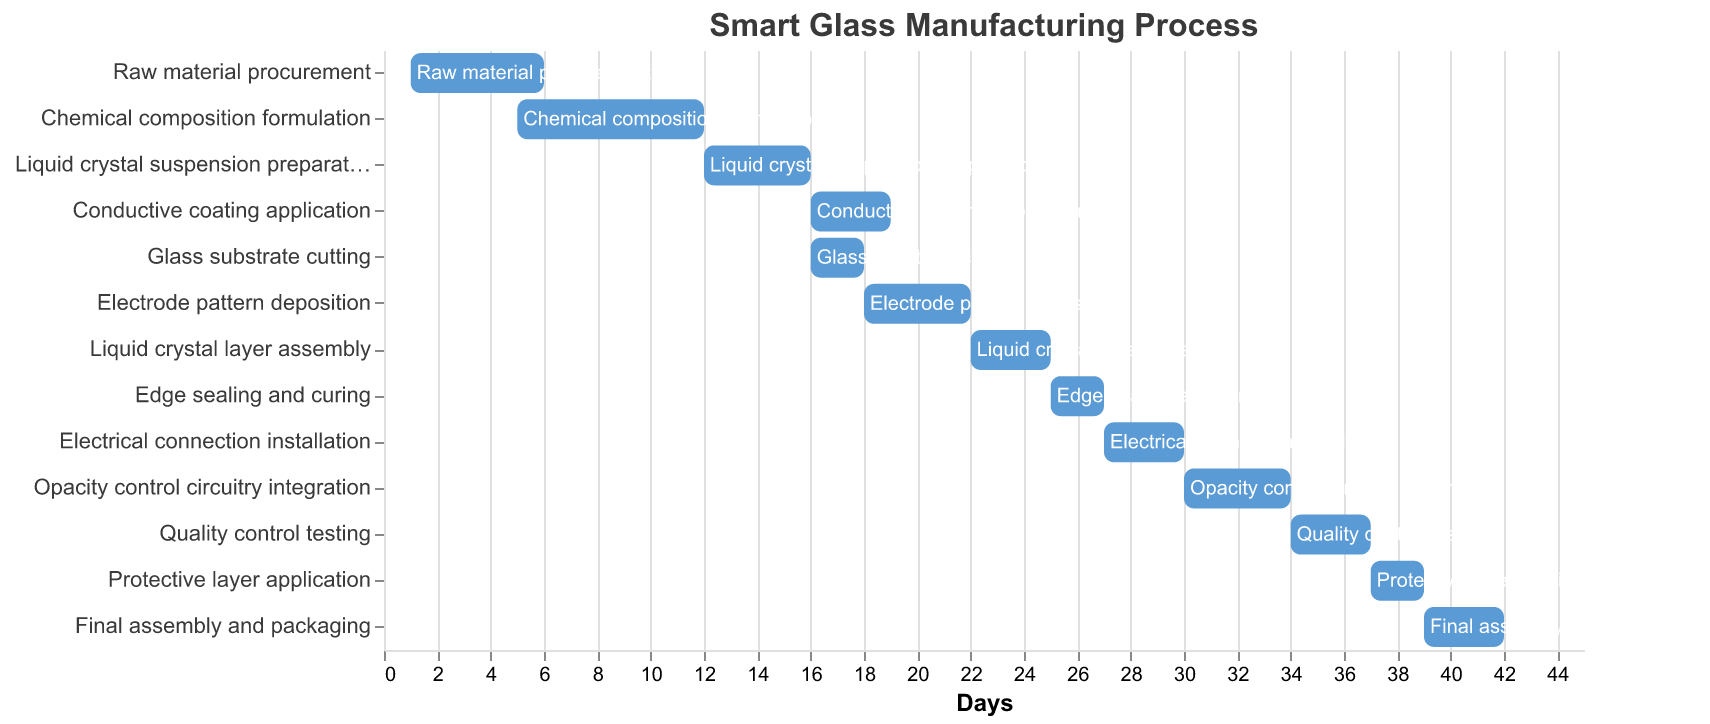What is the task with the longest duration? To find the task with the longest duration, look at the "Duration" field for each task and compare. "Chemical composition formulation" lasts for 7 days, which is the longest.
Answer: Chemical composition formulation When does the "Electrode pattern deposition" task start and end? Refer to the "Start" and "Duration" fields for "Electrode pattern deposition". It starts on day 18 and lasts 4 days. Thus, it ends on day 22 (18 + 4 = 22).
Answer: Starts on day 18 and ends on day 22 Which tasks overlap exactly in their start days? Identify tasks with the same "Start" day. "Conductive coating application" and "Glass substrate cutting" both start on day 16.
Answer: Conductive coating application and Glass substrate cutting What is the total duration of tasks starting before day 10? Identify tasks starting before day 10: "Raw material procurement" (5 days) and "Chemical composition formulation" (7 days started at day 5, but overlapping counts). Total duration is the sum of these, as per their "Duration" fields.
Answer: 12 days When does the final task, "Final assembly and packaging," finish? Look at the "Start" and "Duration" of "Final assembly and packaging". It starts on day 39 and lasts 3 days, so it ends on day 42 (39 + 3 = 42).
Answer: Day 42 How many tasks take exactly 3 days to complete? Check the "Duration" field for tasks lasting 3 days: "Conductive coating application", "Liquid crystal layer assembly", "Electrical connection installation", "Opacity control circuitry integration", "Quality control testing", and "Final assembly and packaging".
Answer: Six tasks What is the average task duration for tasks starting after day 10? Identify tasks starting after day 10 and their durations: "Liquid crystal suspension preparation" (4 days), "Conductive coating application" (3 days), "Glass substrate cutting" (2 days), "Electrode pattern deposition" (4 days), "Liquid crystal layer assembly" (3 days), "Edge sealing and curing" (2 days), "Electrical connection installation" (3 days), "Opacity control circuitry integration" (4 days), "Quality control testing" (3 days), "Protective layer application" (2 days), "Final assembly and packaging" (3 days). Average duration = (4+3+2+4+3+2+3+4+3+2+3)/11 = 3
Answer: 3 days What is the most common task duration? By counting the occurrences of each "Duration", the most common duration in the list is 3 days which occurs the most frequently.
Answer: 3 days 